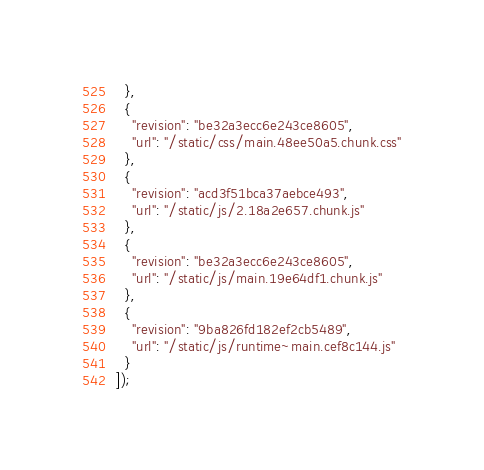Convert code to text. <code><loc_0><loc_0><loc_500><loc_500><_JavaScript_>  },
  {
    "revision": "be32a3ecc6e243ce8605",
    "url": "/static/css/main.48ee50a5.chunk.css"
  },
  {
    "revision": "acd3f51bca37aebce493",
    "url": "/static/js/2.18a2e657.chunk.js"
  },
  {
    "revision": "be32a3ecc6e243ce8605",
    "url": "/static/js/main.19e64df1.chunk.js"
  },
  {
    "revision": "9ba826fd182ef2cb5489",
    "url": "/static/js/runtime~main.cef8c144.js"
  }
]);</code> 